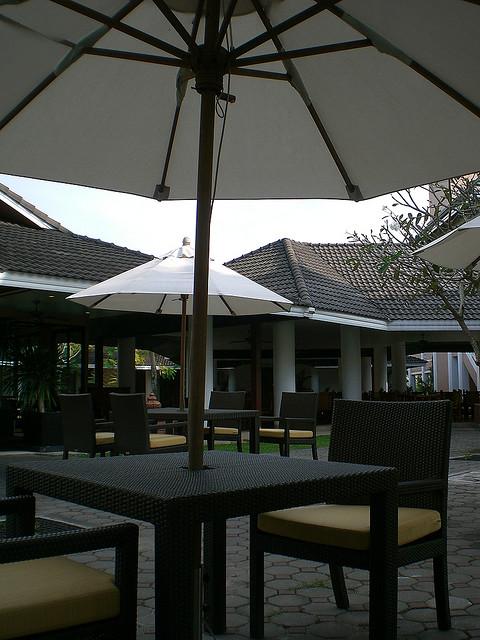How many people are sitting at the table to the left?
Keep it brief. 0. Are there people in the picture?
Write a very short answer. No. Are there vines on the Arbor?
Concise answer only. No. Is this a patio?
Give a very brief answer. Yes. What type of floor is this?
Answer briefly. Brick. What colors are the umbrella?
Answer briefly. White. Was this picture taken inside the building?
Concise answer only. No. Is there a beach?
Write a very short answer. No. What color are the umbrellas over the bistro chairs?
Short answer required. White. What is sticking up from the center of the table?
Be succinct. Umbrella. What color is the umbrella?
Quick response, please. White. 